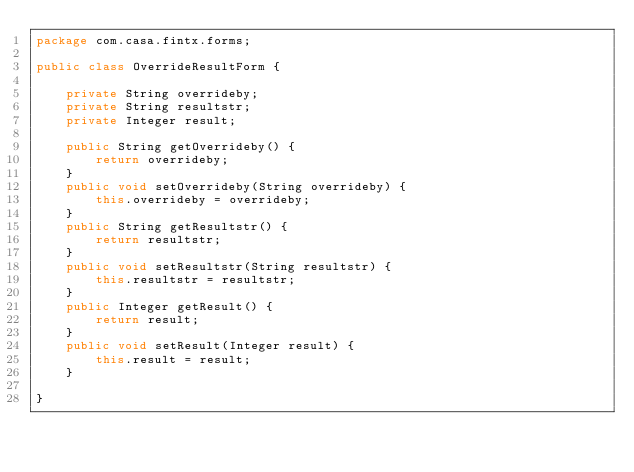Convert code to text. <code><loc_0><loc_0><loc_500><loc_500><_Java_>package com.casa.fintx.forms;

public class OverrideResultForm {

	private String overrideby;
	private String resultstr;
	private Integer result;
	
	public String getOverrideby() {
		return overrideby;
	}
	public void setOverrideby(String overrideby) {
		this.overrideby = overrideby;
	}
	public String getResultstr() {
		return resultstr;
	}
	public void setResultstr(String resultstr) {
		this.resultstr = resultstr;
	}
	public Integer getResult() {
		return result;
	}
	public void setResult(Integer result) {
		this.result = result;
	}
	
}
</code> 